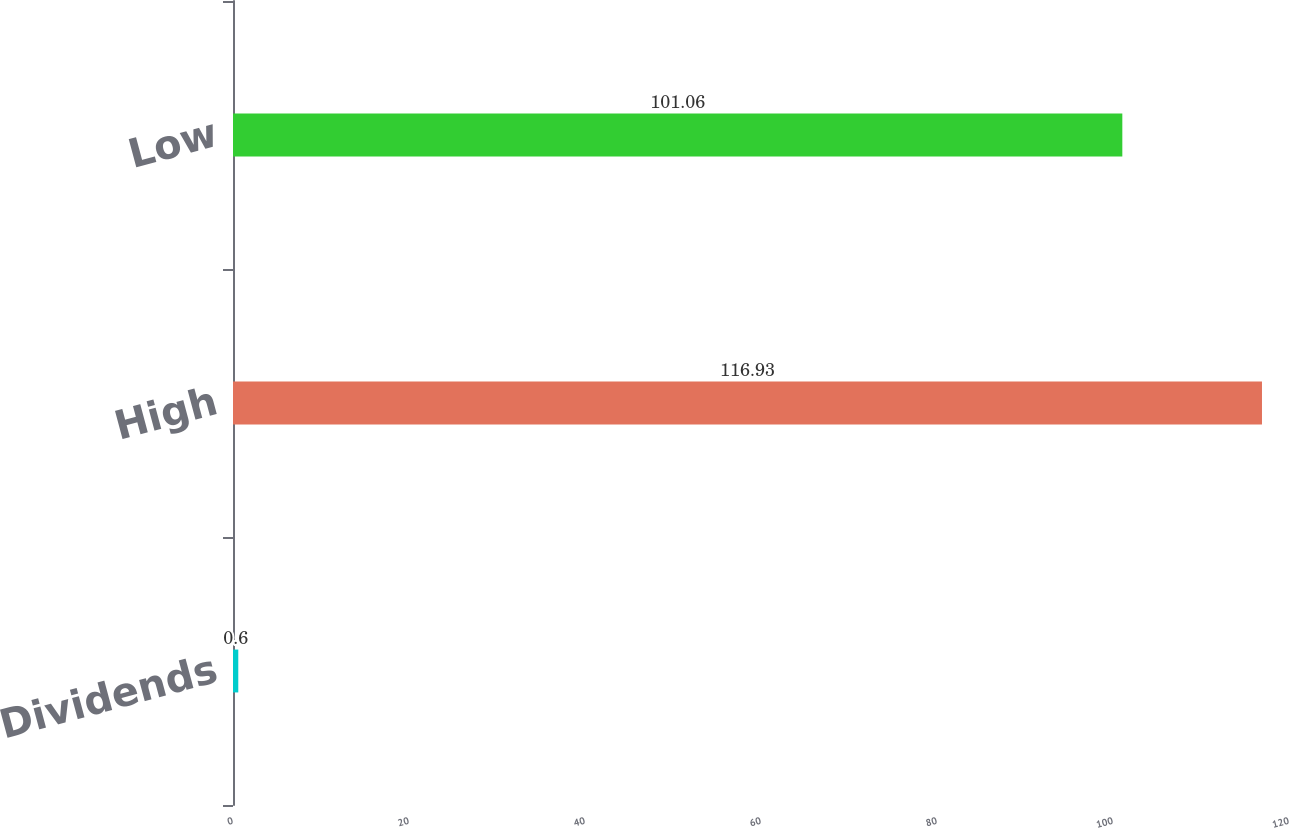<chart> <loc_0><loc_0><loc_500><loc_500><bar_chart><fcel>Dividends<fcel>High<fcel>Low<nl><fcel>0.6<fcel>116.93<fcel>101.06<nl></chart> 